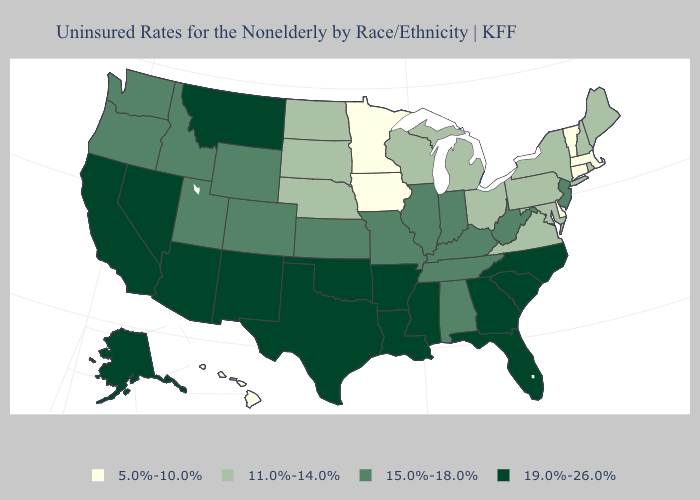Among the states that border Idaho , does Nevada have the highest value?
Short answer required. Yes. Name the states that have a value in the range 19.0%-26.0%?
Answer briefly. Alaska, Arizona, Arkansas, California, Florida, Georgia, Louisiana, Mississippi, Montana, Nevada, New Mexico, North Carolina, Oklahoma, South Carolina, Texas. Among the states that border Indiana , does Illinois have the lowest value?
Concise answer only. No. Does Ohio have the lowest value in the USA?
Quick response, please. No. What is the highest value in the Northeast ?
Concise answer only. 15.0%-18.0%. Does Nebraska have the highest value in the MidWest?
Be succinct. No. What is the highest value in states that border West Virginia?
Be succinct. 15.0%-18.0%. What is the lowest value in the USA?
Quick response, please. 5.0%-10.0%. What is the value of Arizona?
Short answer required. 19.0%-26.0%. What is the highest value in the USA?
Give a very brief answer. 19.0%-26.0%. Does Minnesota have the lowest value in the USA?
Keep it brief. Yes. What is the value of North Dakota?
Answer briefly. 11.0%-14.0%. Among the states that border Indiana , does Kentucky have the lowest value?
Concise answer only. No. Among the states that border Iowa , which have the highest value?
Answer briefly. Illinois, Missouri. Name the states that have a value in the range 11.0%-14.0%?
Give a very brief answer. Maine, Maryland, Michigan, Nebraska, New Hampshire, New York, North Dakota, Ohio, Pennsylvania, Rhode Island, South Dakota, Virginia, Wisconsin. 